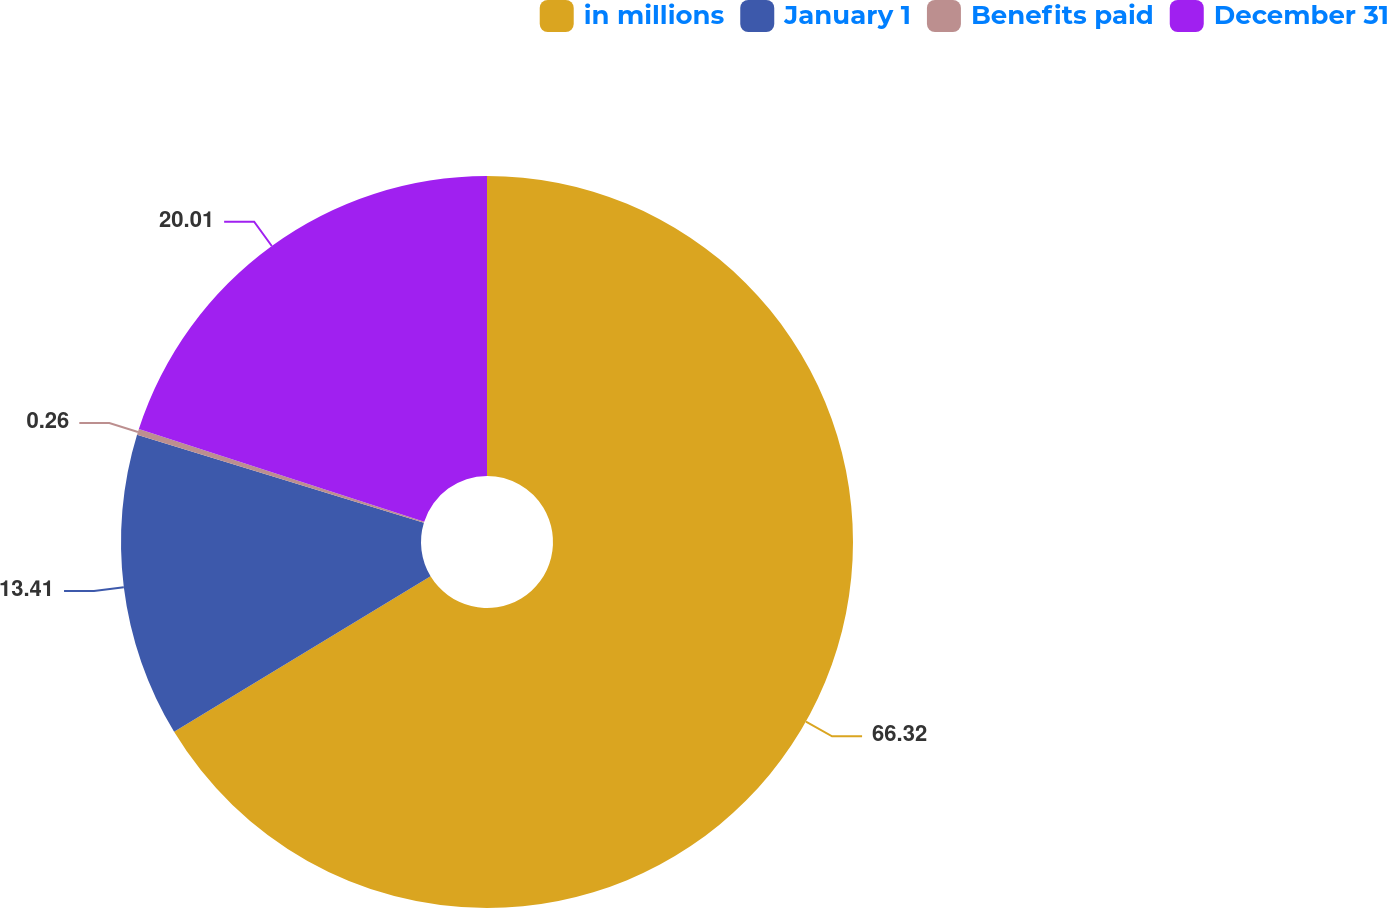<chart> <loc_0><loc_0><loc_500><loc_500><pie_chart><fcel>in millions<fcel>January 1<fcel>Benefits paid<fcel>December 31<nl><fcel>66.32%<fcel>13.41%<fcel>0.26%<fcel>20.01%<nl></chart> 